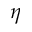<formula> <loc_0><loc_0><loc_500><loc_500>\eta</formula> 